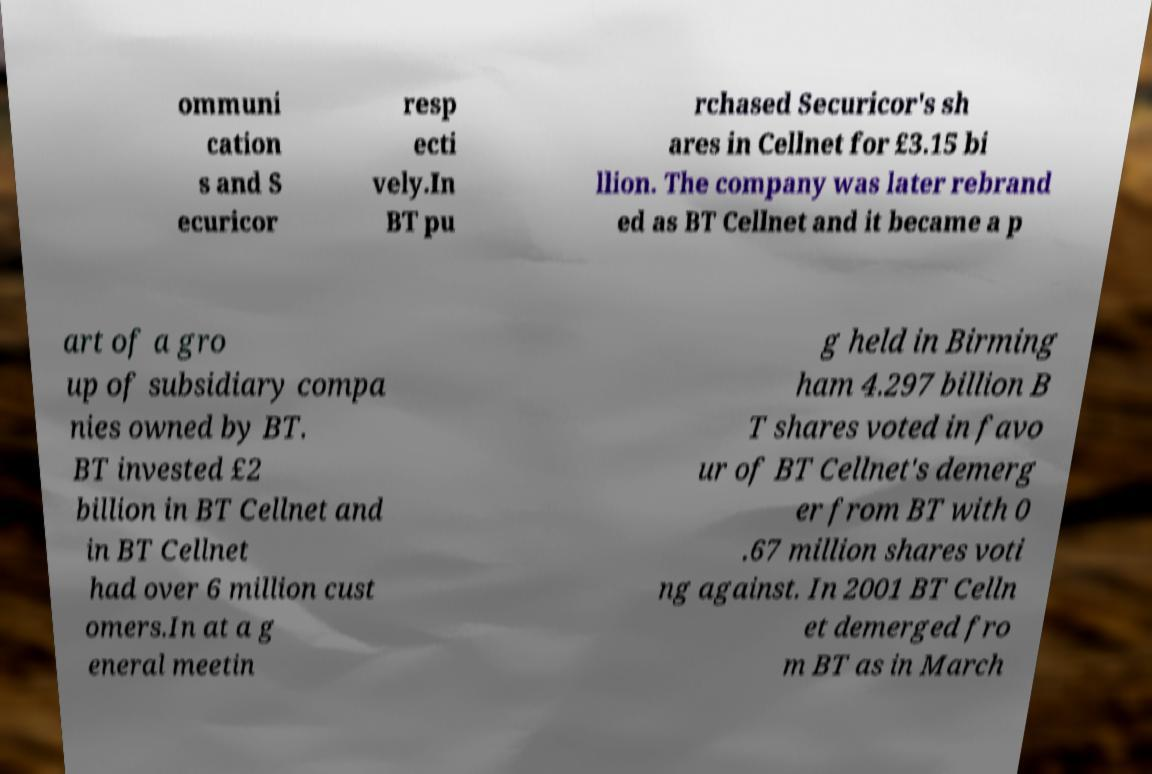Could you extract and type out the text from this image? ommuni cation s and S ecuricor resp ecti vely.In BT pu rchased Securicor's sh ares in Cellnet for £3.15 bi llion. The company was later rebrand ed as BT Cellnet and it became a p art of a gro up of subsidiary compa nies owned by BT. BT invested £2 billion in BT Cellnet and in BT Cellnet had over 6 million cust omers.In at a g eneral meetin g held in Birming ham 4.297 billion B T shares voted in favo ur of BT Cellnet's demerg er from BT with 0 .67 million shares voti ng against. In 2001 BT Celln et demerged fro m BT as in March 